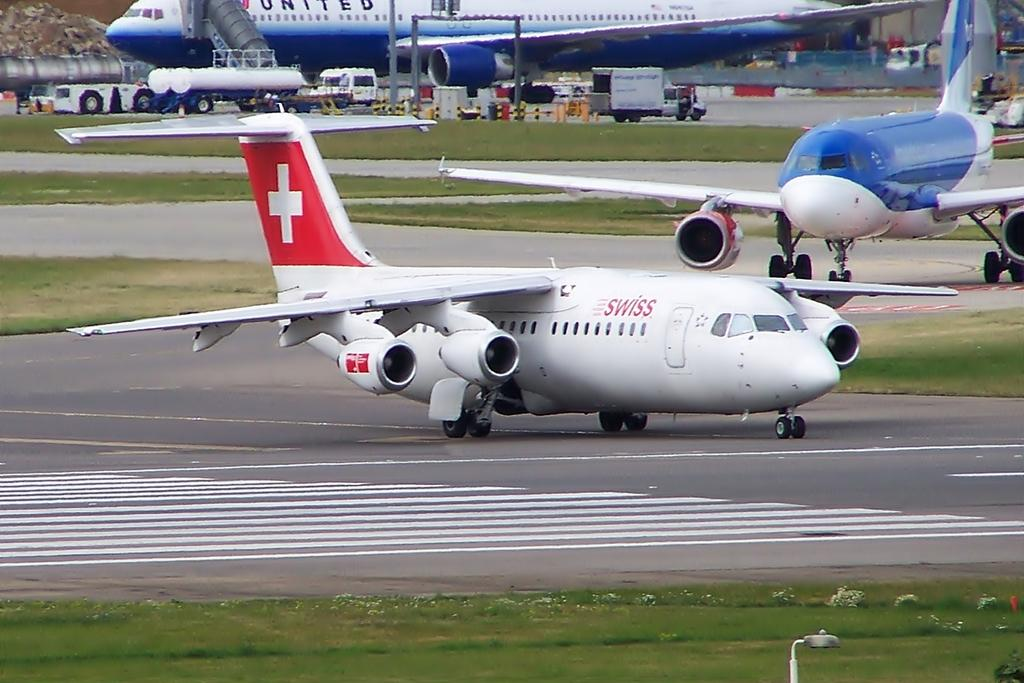<image>
Provide a brief description of the given image. A small airplane on a runway from the brand SWISS. 